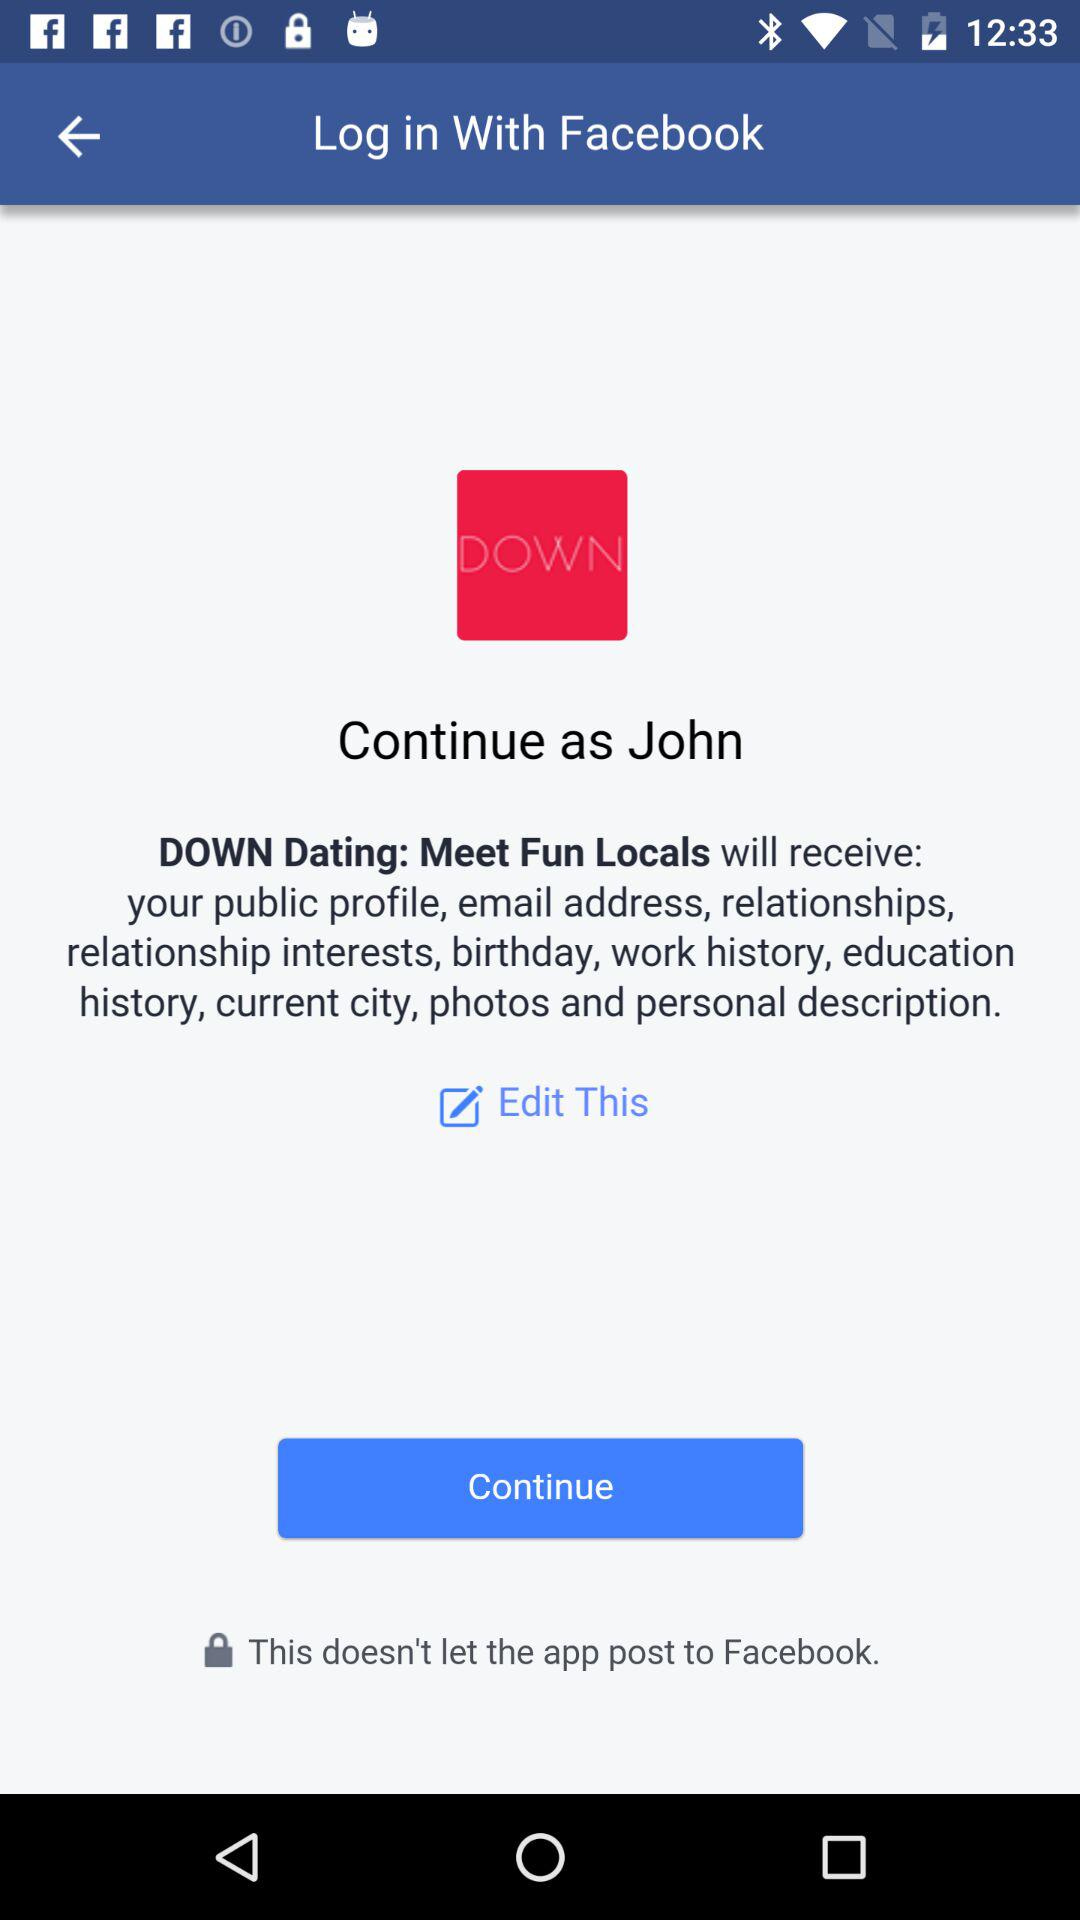What is the user name? The user name is John. 